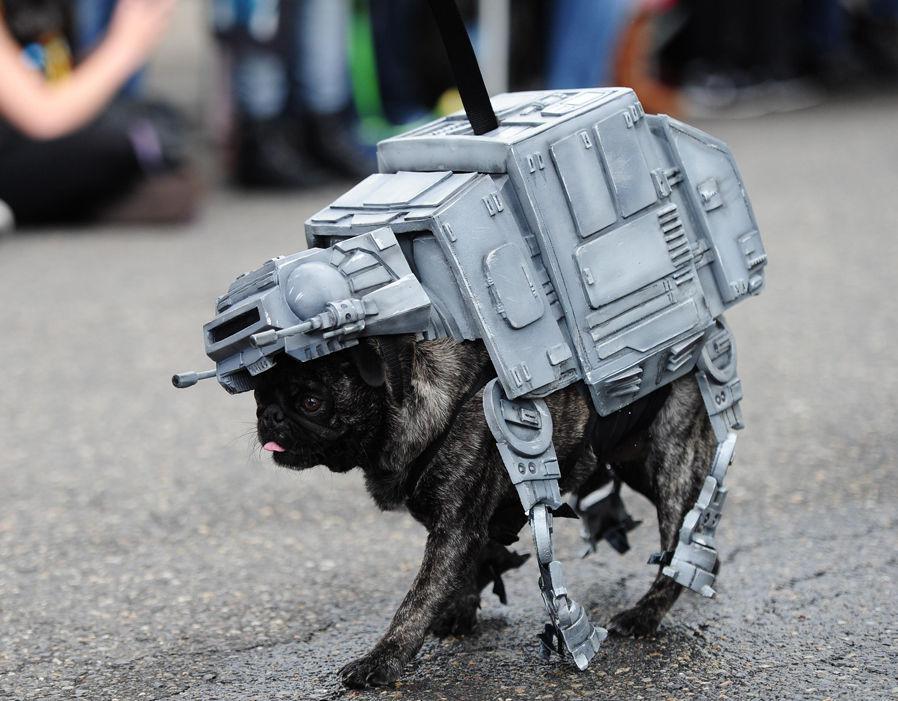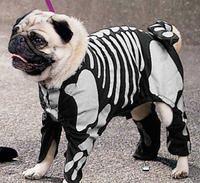The first image is the image on the left, the second image is the image on the right. Evaluate the accuracy of this statement regarding the images: "One image shows a beige pug in a white 'sheet' leaning its face into a black pug wearing a skeleton costume.". Is it true? Answer yes or no. No. The first image is the image on the left, the second image is the image on the right. For the images displayed, is the sentence "There is one dog touching another dog with their face in one of the images." factually correct? Answer yes or no. No. 